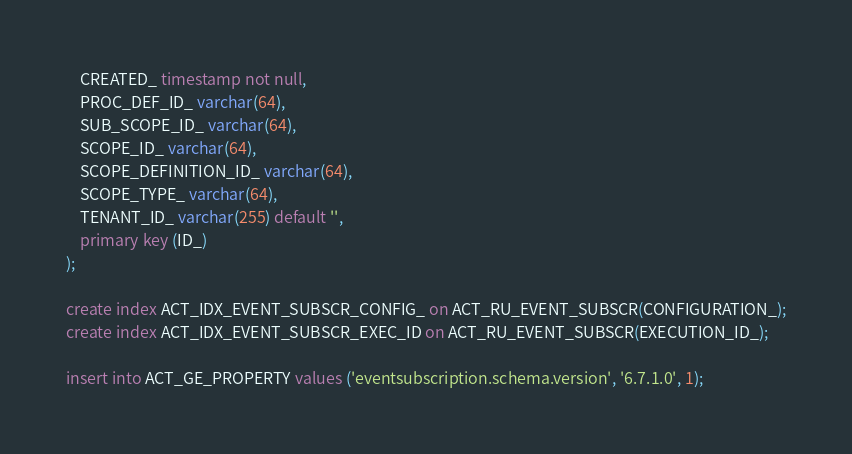<code> <loc_0><loc_0><loc_500><loc_500><_SQL_>    CREATED_ timestamp not null,
    PROC_DEF_ID_ varchar(64),
    SUB_SCOPE_ID_ varchar(64),
    SCOPE_ID_ varchar(64),
    SCOPE_DEFINITION_ID_ varchar(64),
    SCOPE_TYPE_ varchar(64),
    TENANT_ID_ varchar(255) default '',
    primary key (ID_)
);

create index ACT_IDX_EVENT_SUBSCR_CONFIG_ on ACT_RU_EVENT_SUBSCR(CONFIGURATION_);
create index ACT_IDX_EVENT_SUBSCR_EXEC_ID on ACT_RU_EVENT_SUBSCR(EXECUTION_ID_);

insert into ACT_GE_PROPERTY values ('eventsubscription.schema.version', '6.7.1.0', 1);
</code> 